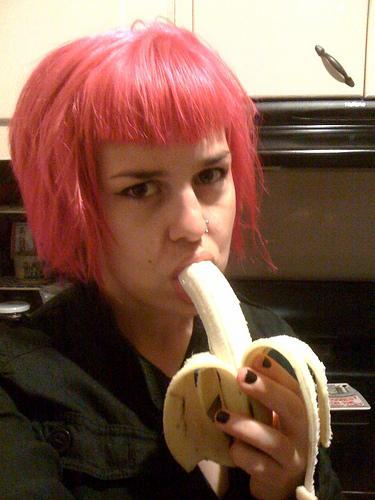Question: who is in the picture?
Choices:
A. A lady.
B. A man.
C. A girl.
D. A boy.
Answer with the letter. Answer: A Question: what color is her hair?
Choices:
A. Pink.
B. Red.
C. Blue.
D. Brown.
Answer with the letter. Answer: A Question: what color are the woman's eyes?
Choices:
A. Blue.
B. Green.
C. Gray.
D. Brown.
Answer with the letter. Answer: D Question: where is the person looking?
Choices:
A. The sea.
B. The mountains.
C. At the camera.
D. The flowers.
Answer with the letter. Answer: C 